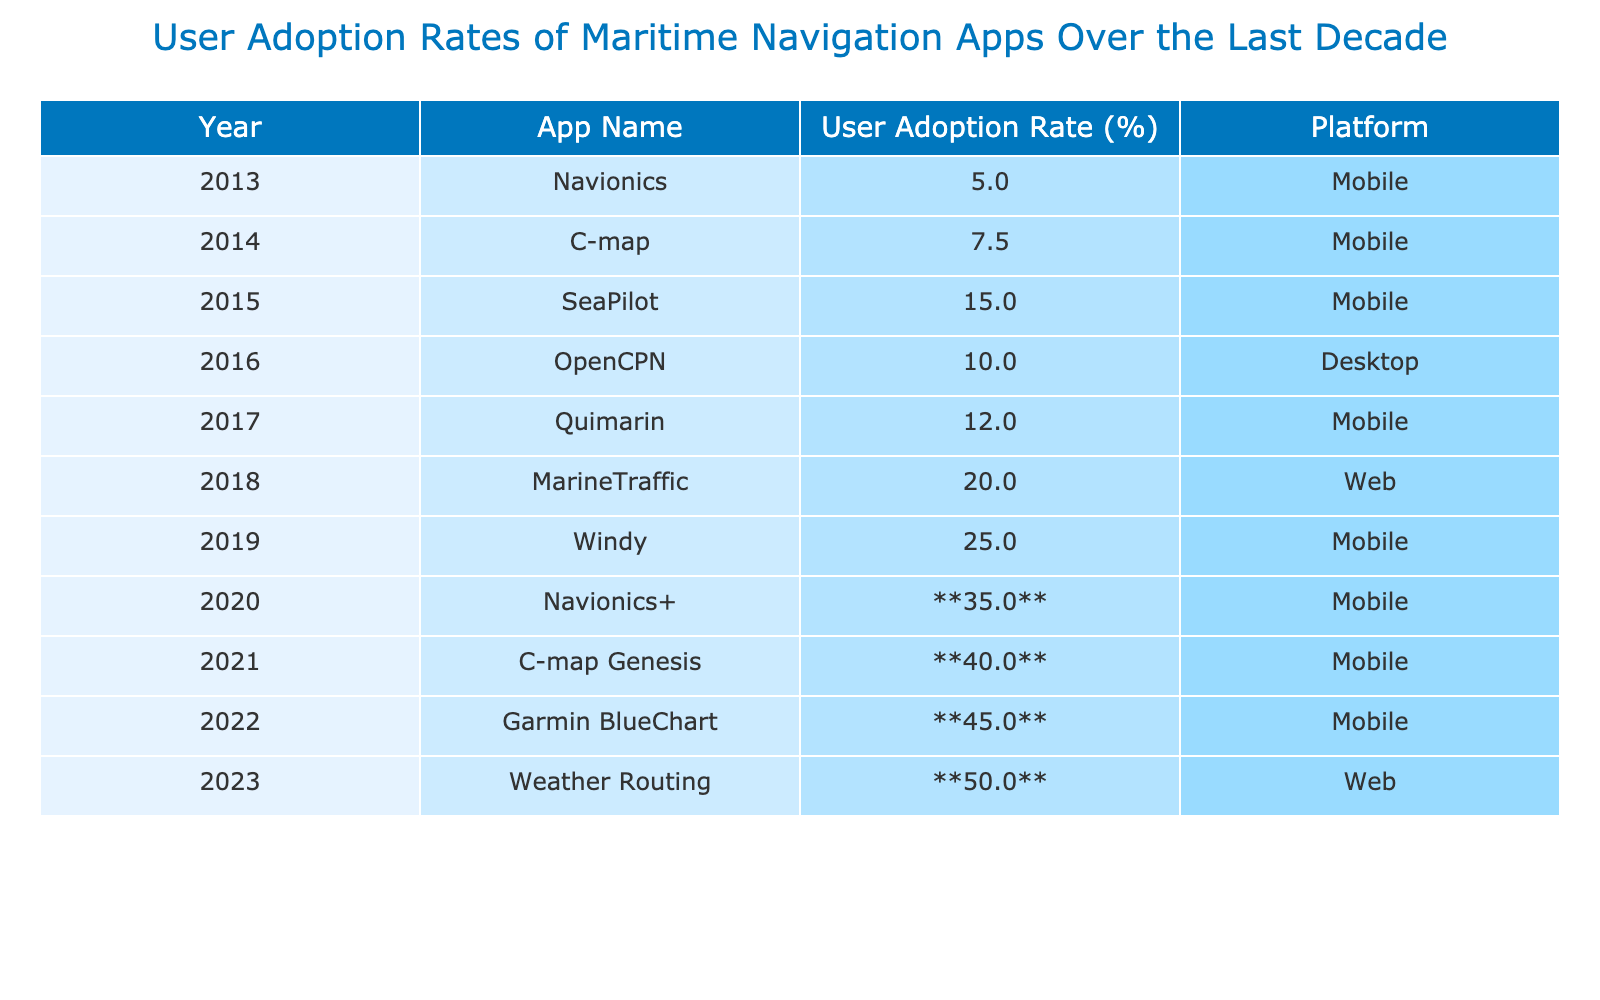What was the user adoption rate of the Navionics app in 2020? According to the table, the user adoption rate of the Navionics app in 2020 is highlighted as **35.0%**.
Answer: 35.0% Which app had the highest user adoption rate in the year 2023? The table indicates that the Weather Routing app had a user adoption rate of **50.0%**, which is the highest in the year 2023.
Answer: 50.0% What is the difference in user adoption rates between Windy in 2019 and C-map Genesis in 2021? The user adoption rate for Windy in 2019 is 25.0%, and for C-map Genesis in 2021 it is **40.0%**. The difference is calculated as 40.0% - 25.0% = 15.0%.
Answer: 15.0% Did the user adoption rates generally increase over the years from 2013 to 2023? By looking at the table, the user adoption rates show a consistent increase from 5.0% in 2013 to **50.0%** in 2023.
Answer: Yes What was the average user adoption rate for mobile apps over the years listed? For mobile apps listed in the table, the adoption rates are 5.0%, 7.5%, 15.0%, 12.0%, 20.0%, 25.0%, 35.0%, 40.0%. Summing these values gives 5.0 + 7.5 + 15.0 + 12.0 + 20.0 + 25.0 + 35.0 + 40.0 = 155.5%. Dividing by 8 (the number of mobile apps) results in an average of 155.5 / 8 = 19.4375%.
Answer: 19.44% Which app showed the most significant increase in user adoption rate from one year to the next? By analyzing the differences between consecutive years, the greatest increase in adoption appears between 2022 (45.0%) and 2023 (50.0%), which shows an increase of 5.0%. Additionally, Navionics+ from 2020 to 2021 shows a significant rise from 35.0% to **40.0%**, also a 5.0% increase. A tie exists.
Answer: Tie (5.0% increase) 